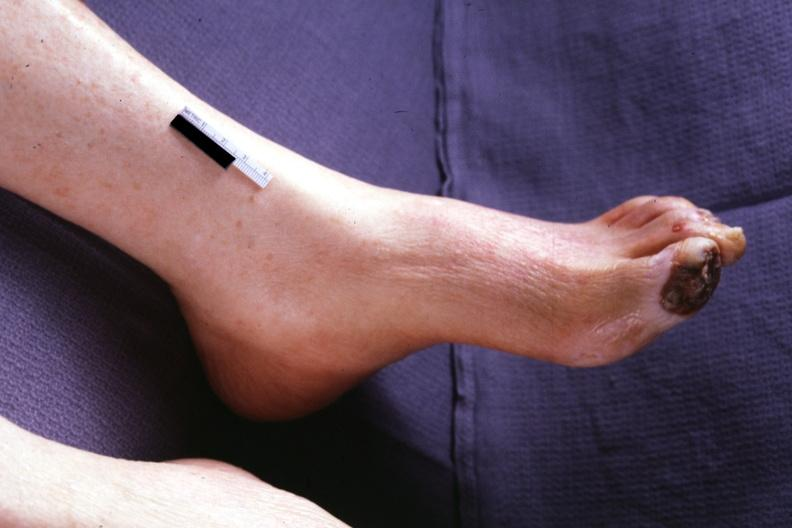does this image show typical gangrene?
Answer the question using a single word or phrase. Yes 